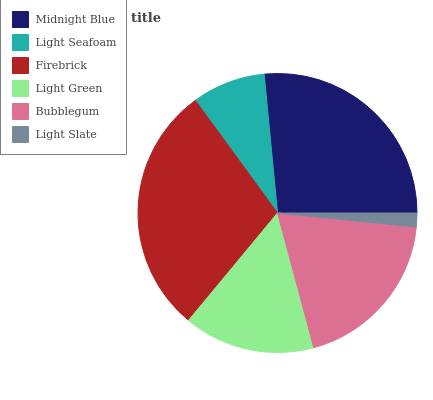Is Light Slate the minimum?
Answer yes or no. Yes. Is Firebrick the maximum?
Answer yes or no. Yes. Is Light Seafoam the minimum?
Answer yes or no. No. Is Light Seafoam the maximum?
Answer yes or no. No. Is Midnight Blue greater than Light Seafoam?
Answer yes or no. Yes. Is Light Seafoam less than Midnight Blue?
Answer yes or no. Yes. Is Light Seafoam greater than Midnight Blue?
Answer yes or no. No. Is Midnight Blue less than Light Seafoam?
Answer yes or no. No. Is Bubblegum the high median?
Answer yes or no. Yes. Is Light Green the low median?
Answer yes or no. Yes. Is Light Seafoam the high median?
Answer yes or no. No. Is Midnight Blue the low median?
Answer yes or no. No. 